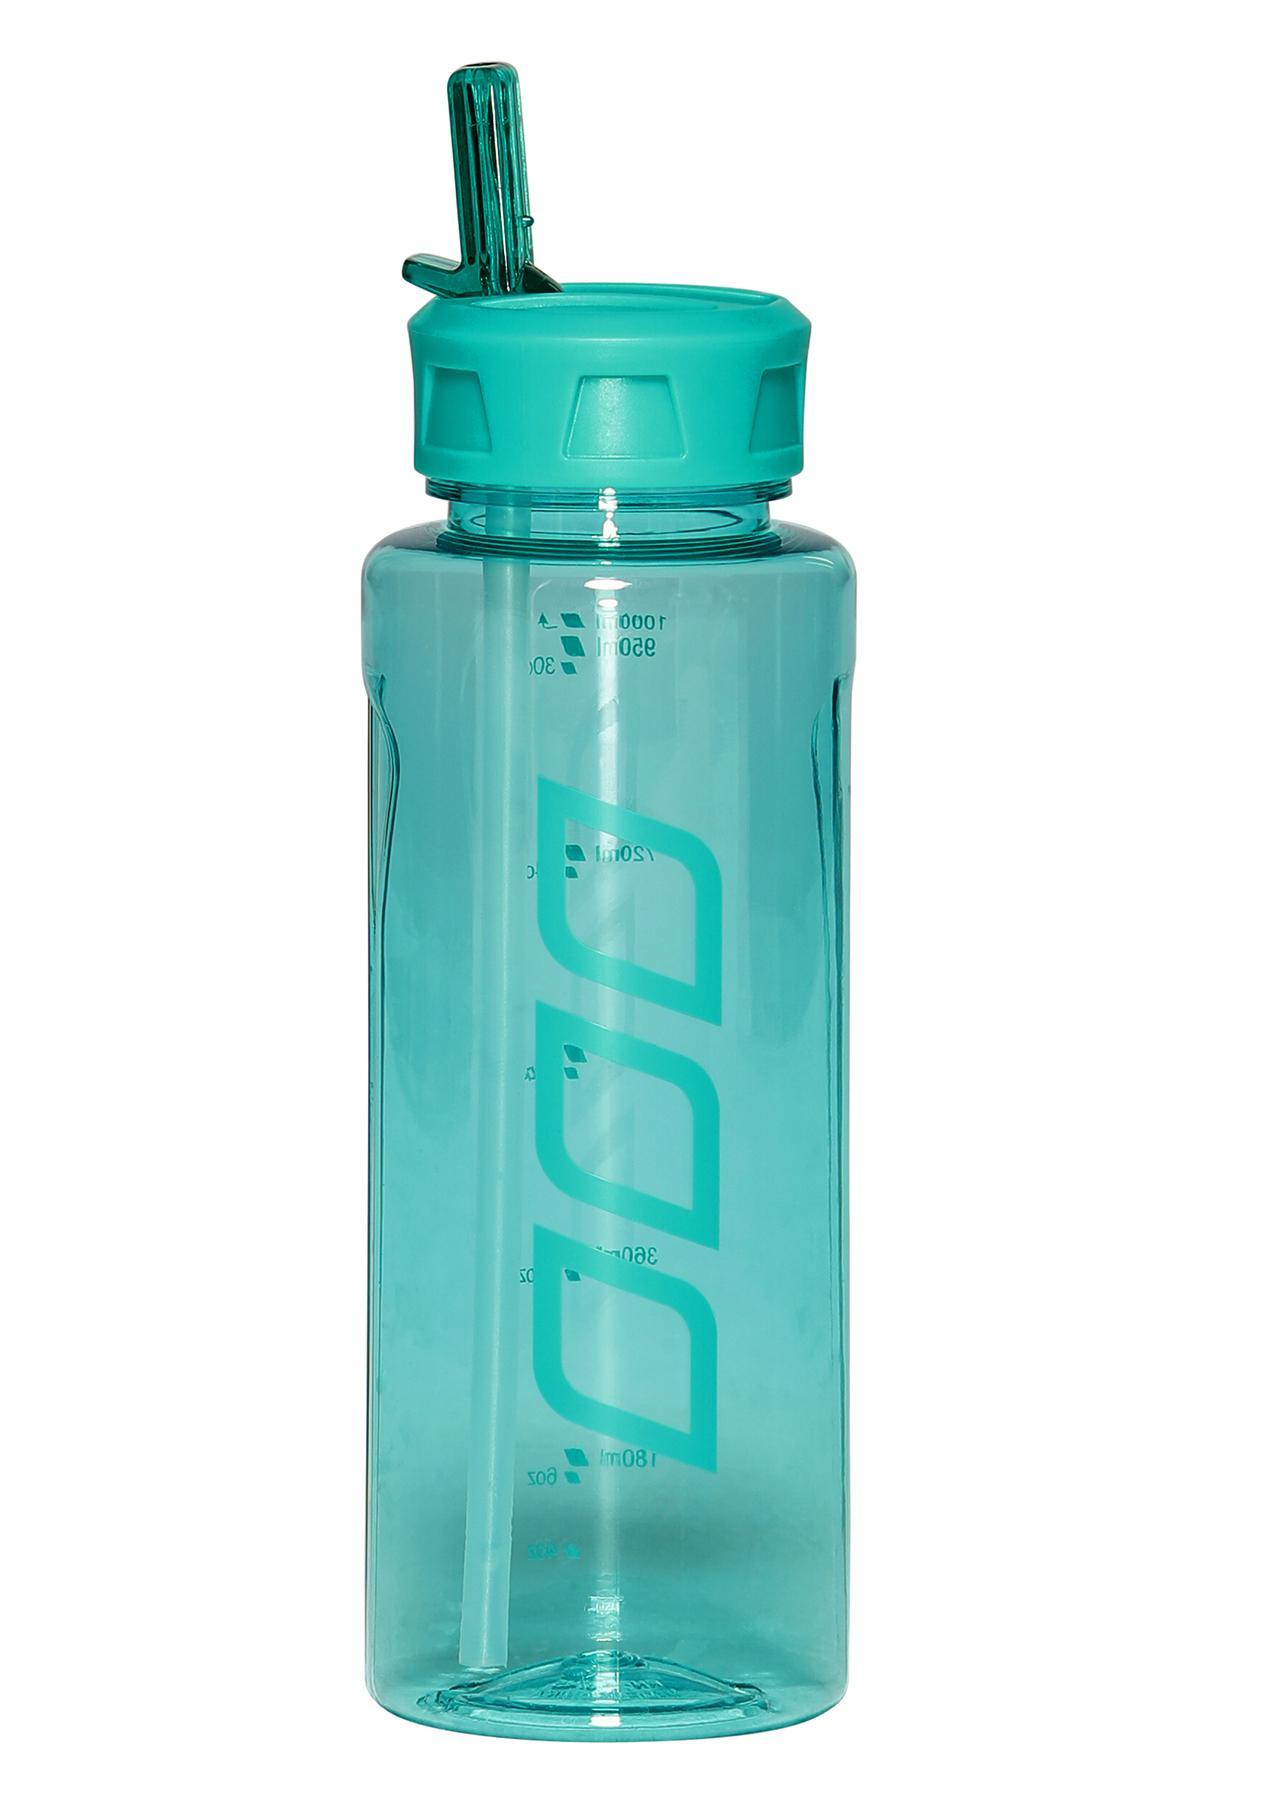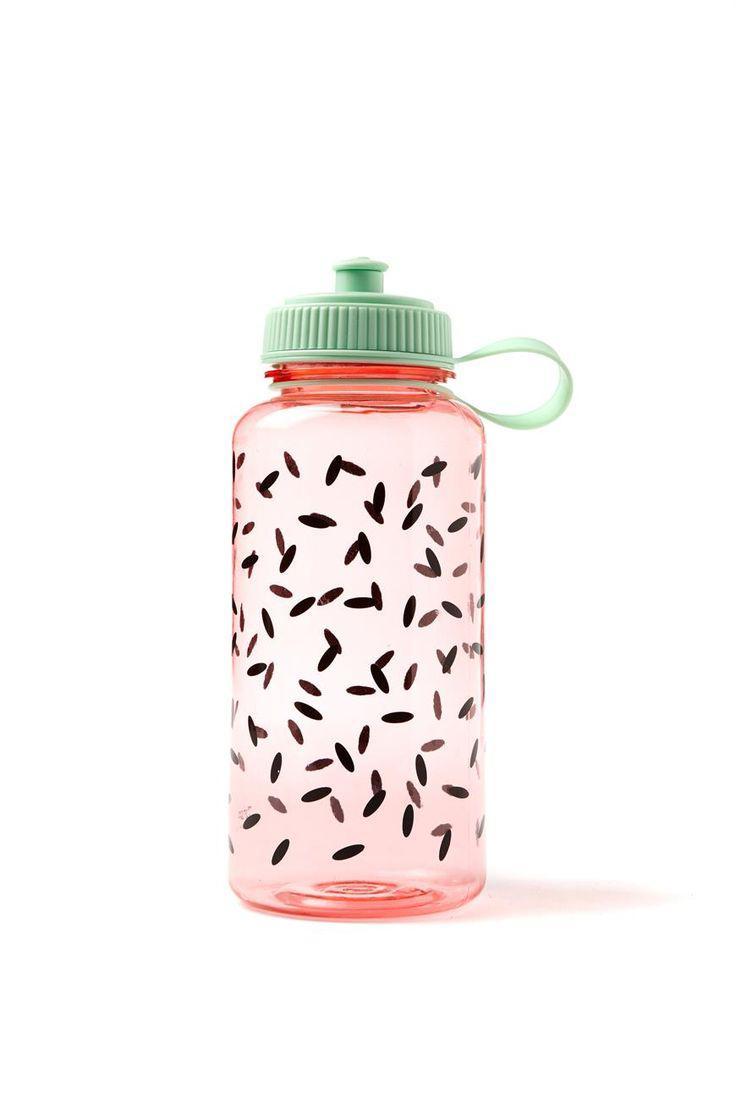The first image is the image on the left, the second image is the image on the right. For the images shown, is this caption "Each image shows a bottle shaped like a cylinder with straight sides, and the water bottle on the right is pink with a pattern of small black ovals and has a green cap with a loop on the right." true? Answer yes or no. Yes. The first image is the image on the left, the second image is the image on the right. Evaluate the accuracy of this statement regarding the images: "Two water bottles both have matching caps, but are different colors and one bottle is much bigger.". Is it true? Answer yes or no. No. 